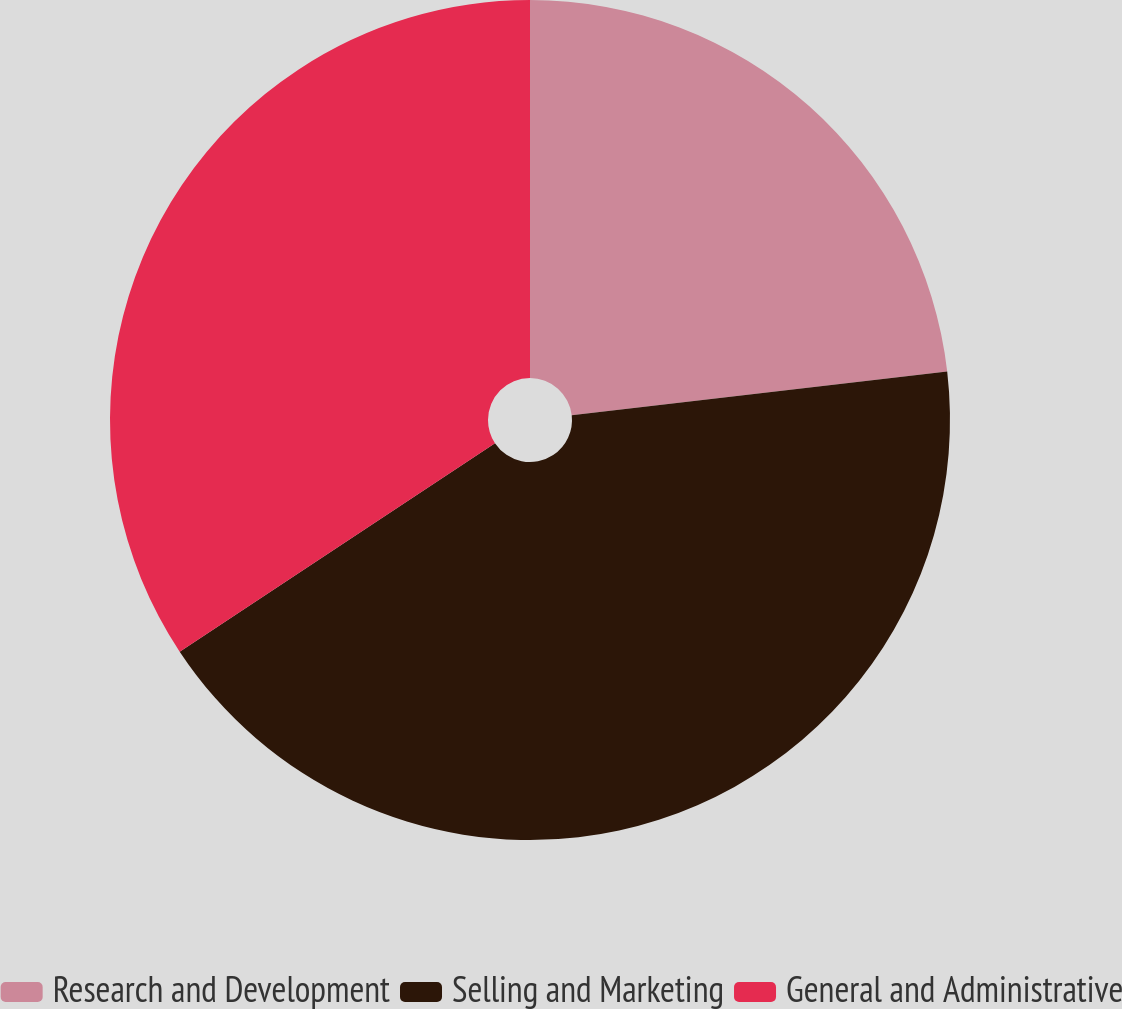Convert chart. <chart><loc_0><loc_0><loc_500><loc_500><pie_chart><fcel>Research and Development<fcel>Selling and Marketing<fcel>General and Administrative<nl><fcel>23.16%<fcel>42.54%<fcel>34.3%<nl></chart> 